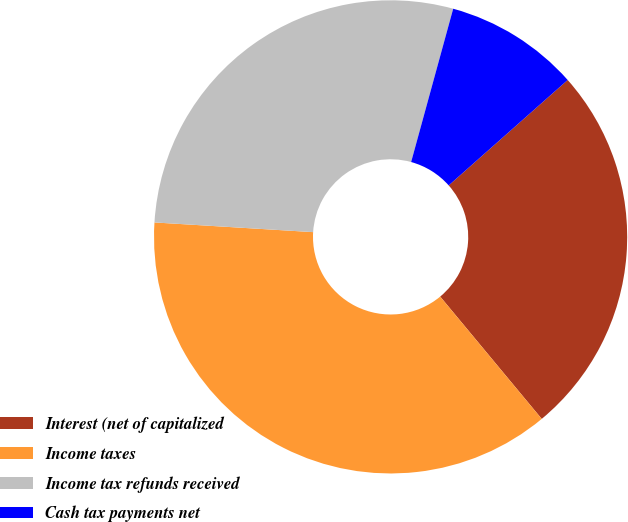<chart> <loc_0><loc_0><loc_500><loc_500><pie_chart><fcel>Interest (net of capitalized<fcel>Income taxes<fcel>Income tax refunds received<fcel>Cash tax payments net<nl><fcel>25.51%<fcel>37.0%<fcel>28.29%<fcel>9.2%<nl></chart> 